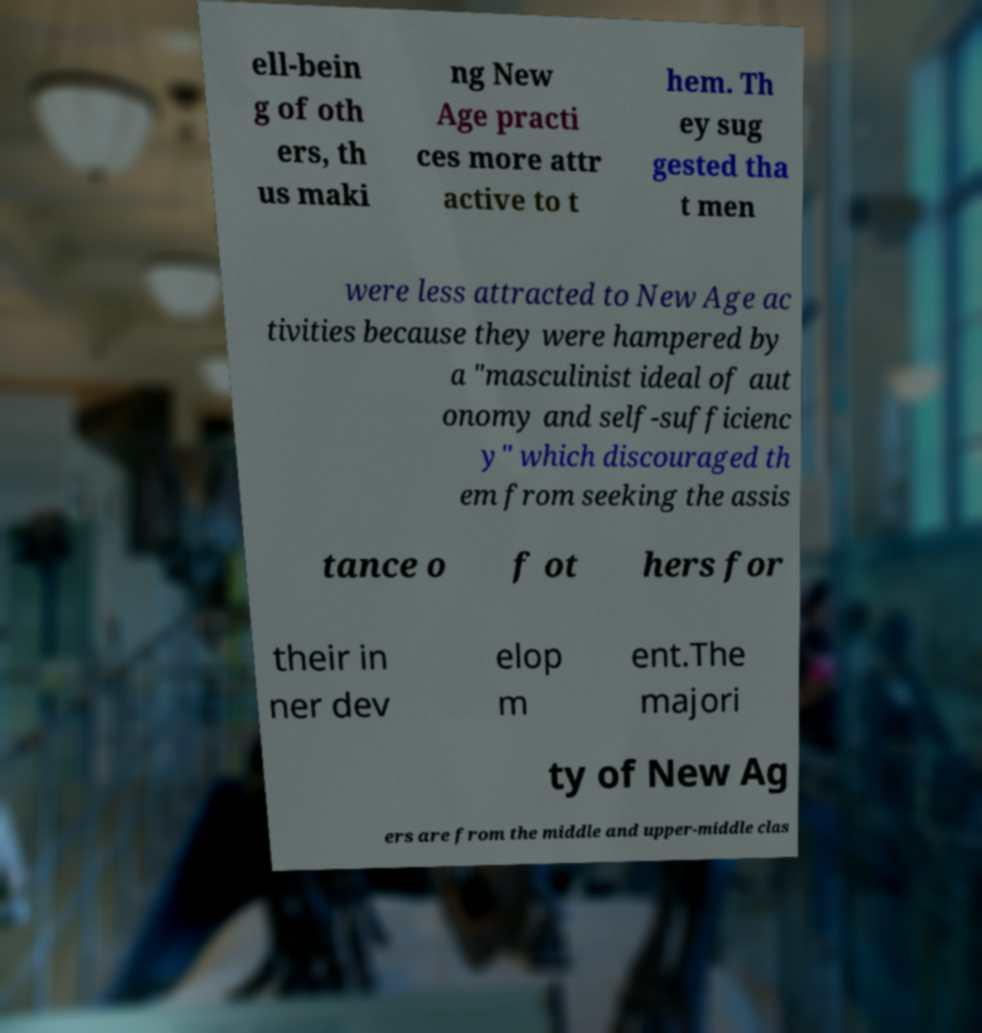What messages or text are displayed in this image? I need them in a readable, typed format. ell-bein g of oth ers, th us maki ng New Age practi ces more attr active to t hem. Th ey sug gested tha t men were less attracted to New Age ac tivities because they were hampered by a "masculinist ideal of aut onomy and self-sufficienc y" which discouraged th em from seeking the assis tance o f ot hers for their in ner dev elop m ent.The majori ty of New Ag ers are from the middle and upper-middle clas 